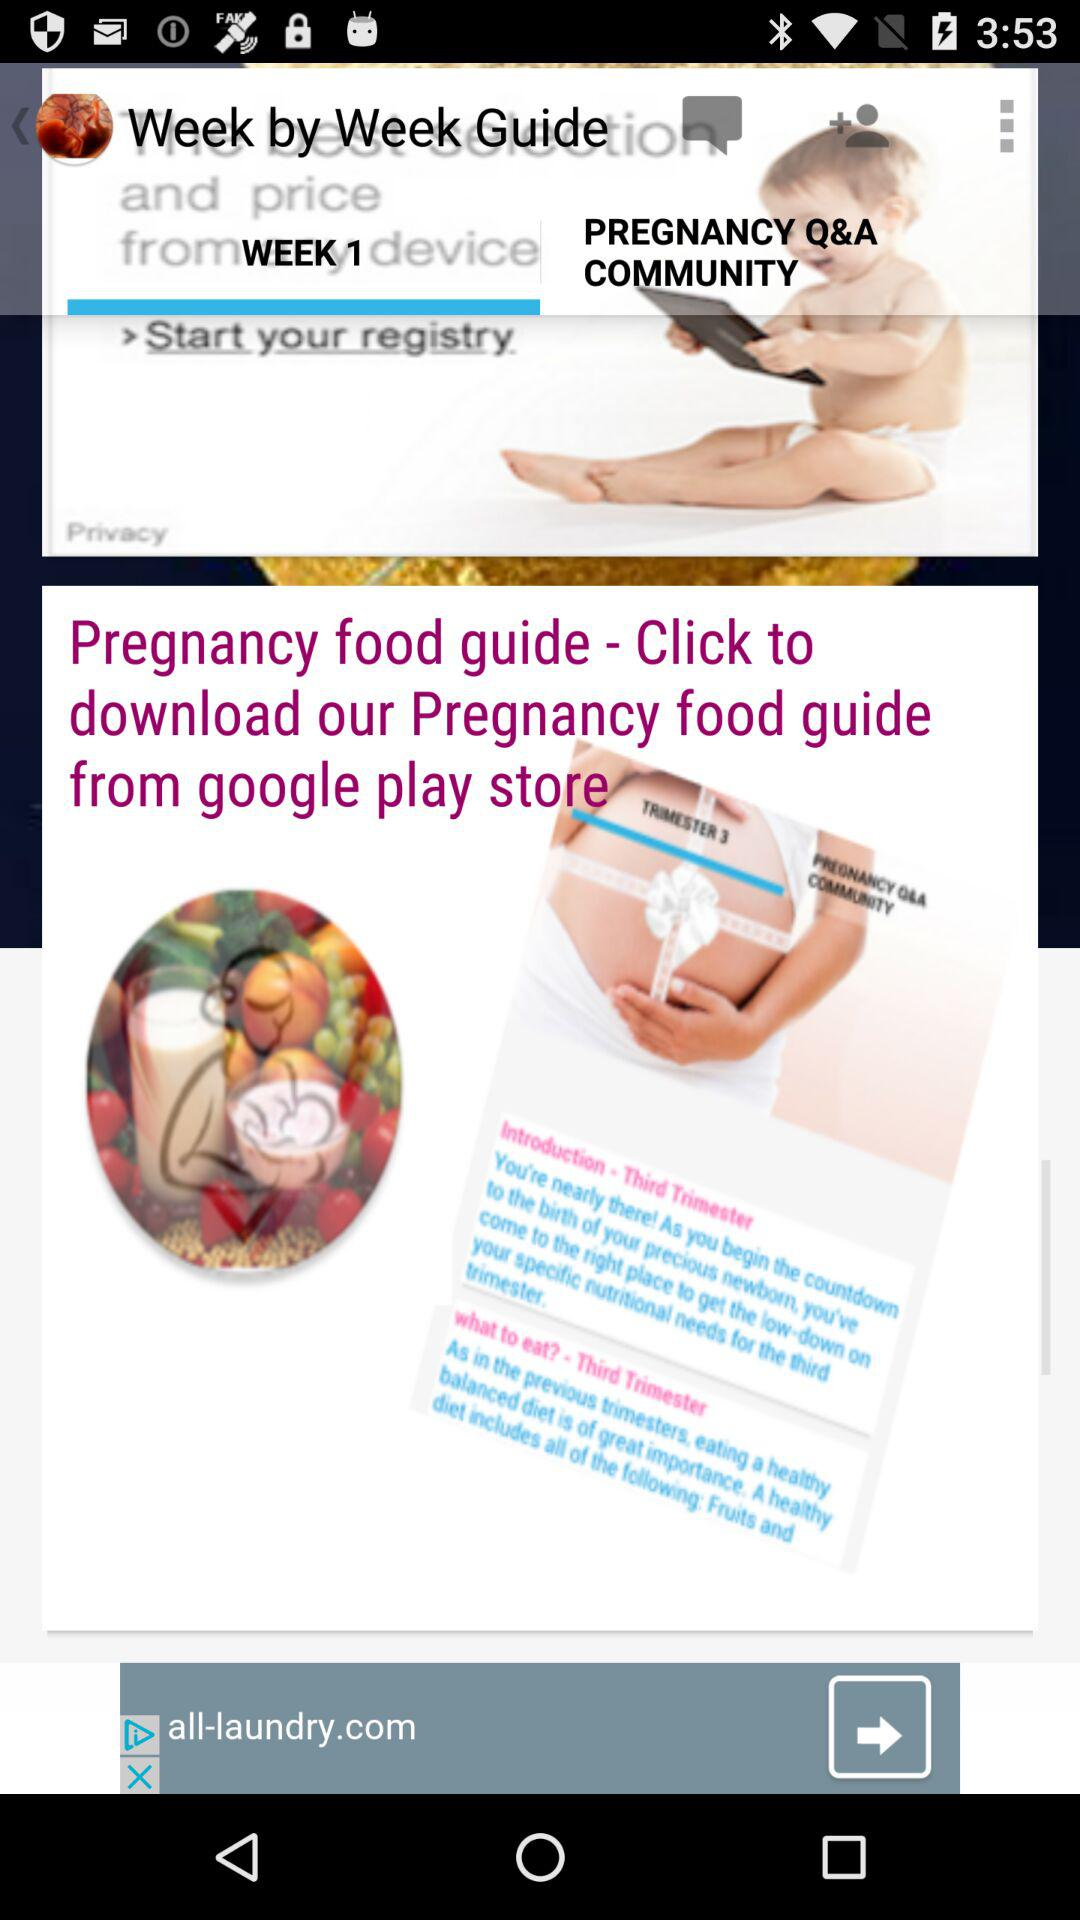From where can we download the "Pregnancy food guide"? You can download the "Pregnancy food guide" from the "google play store". 